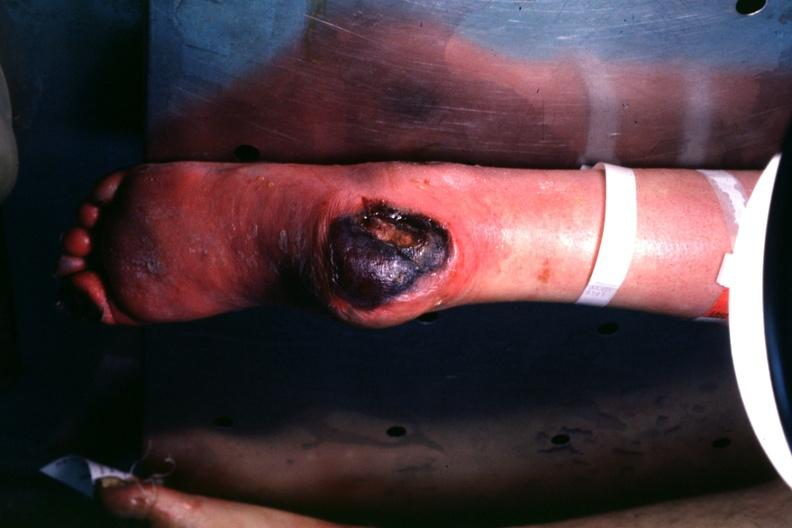s heel ulcer present?
Answer the question using a single word or phrase. Yes 